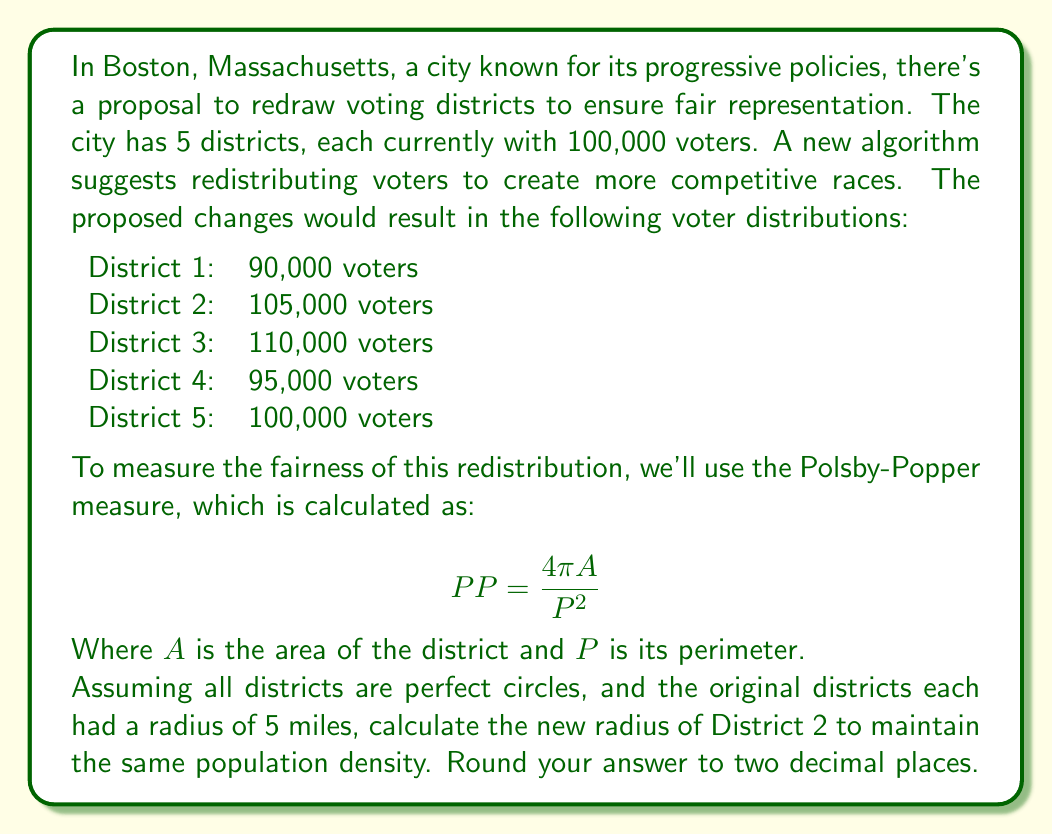Solve this math problem. To solve this problem, we need to follow these steps:

1) First, let's calculate the area of the original districts:
   $A_{original} = \pi r^2 = \pi (5^2) = 25\pi$ square miles

2) Now, we can calculate the population density of the original districts:
   $\text{Density}_{original} = \frac{100,000}{25\pi}$ people per square mile

3) For the new District 2, we want to maintain this density with 105,000 people. Let's call the new radius $r$:

   $\frac{105,000}{\pi r^2} = \frac{100,000}{25\pi}$

4) Simplify the equation:
   $\frac{105,000}{\pi r^2} = \frac{4,000}{\pi}$

5) Multiply both sides by $\pi r^2$:
   $105,000 = 4,000r^2$

6) Divide both sides by 4,000:
   $26.25 = r^2$

7) Take the square root of both sides:
   $r = \sqrt{26.25} \approx 5.12$ miles

Therefore, the new radius of District 2 should be approximately 5.12 miles to maintain the same population density.
Answer: 5.12 miles 